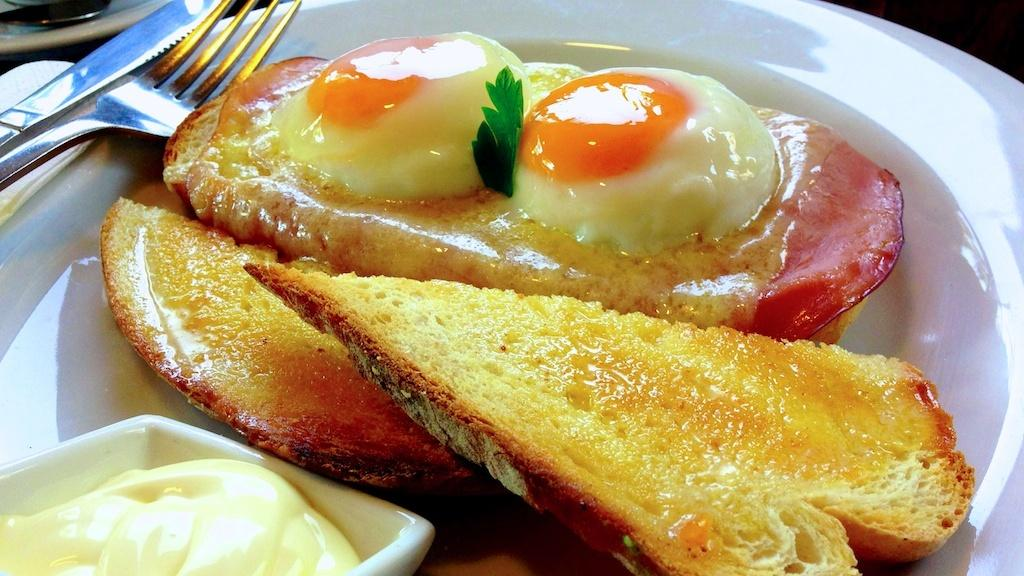What is the focus of the image? The image is zoomed in on a white color palette. What is on the palette? The palette contains food items. What utensils are present on the left side of the image? There is a fork and a knife on the left side of the image. Are there any other items visible on the left side of the image? Yes, there are other items on the left side of the image. Is the writer sitting next to the pig in the image? There is no writer or pig present in the image. 